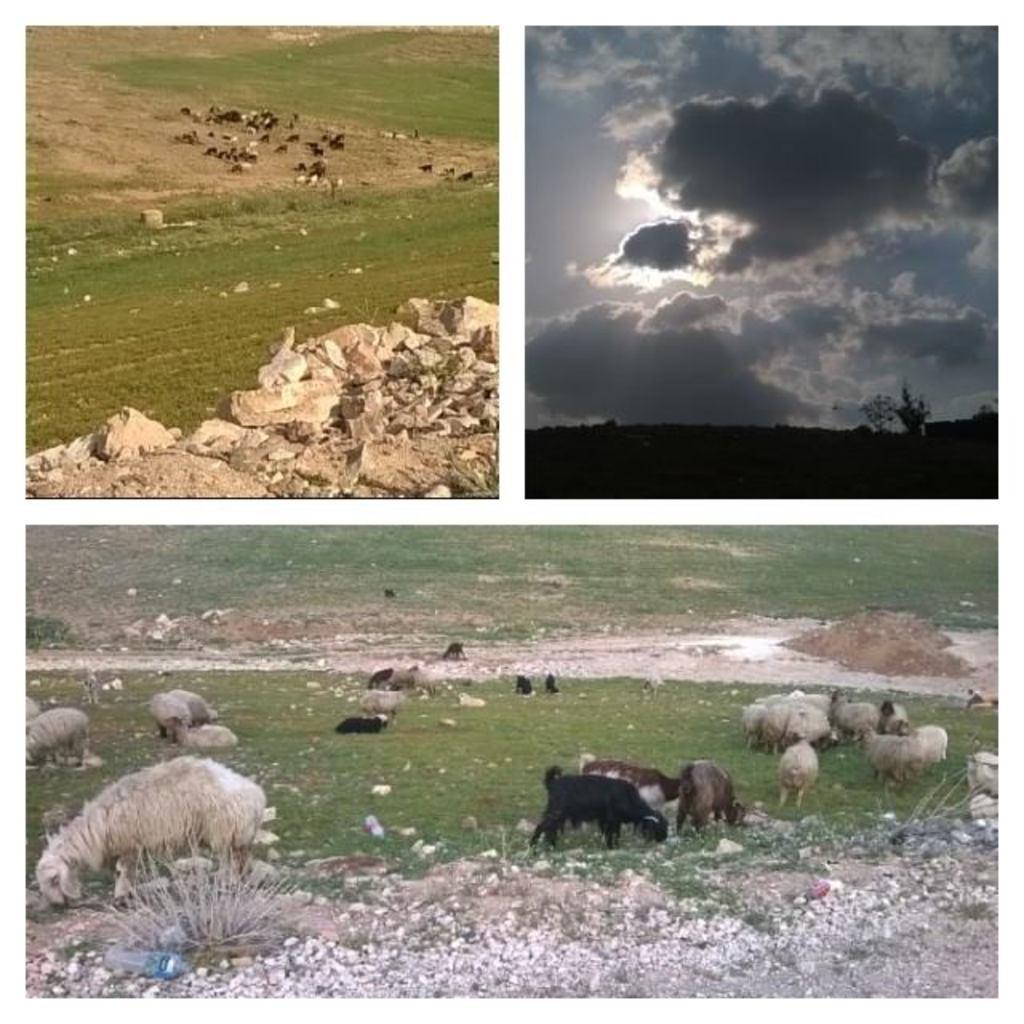Can you describe this image briefly? This is a collage picture. There are animals on the ground. Here we can see grass, bottle, stones, and sky with clouds. 